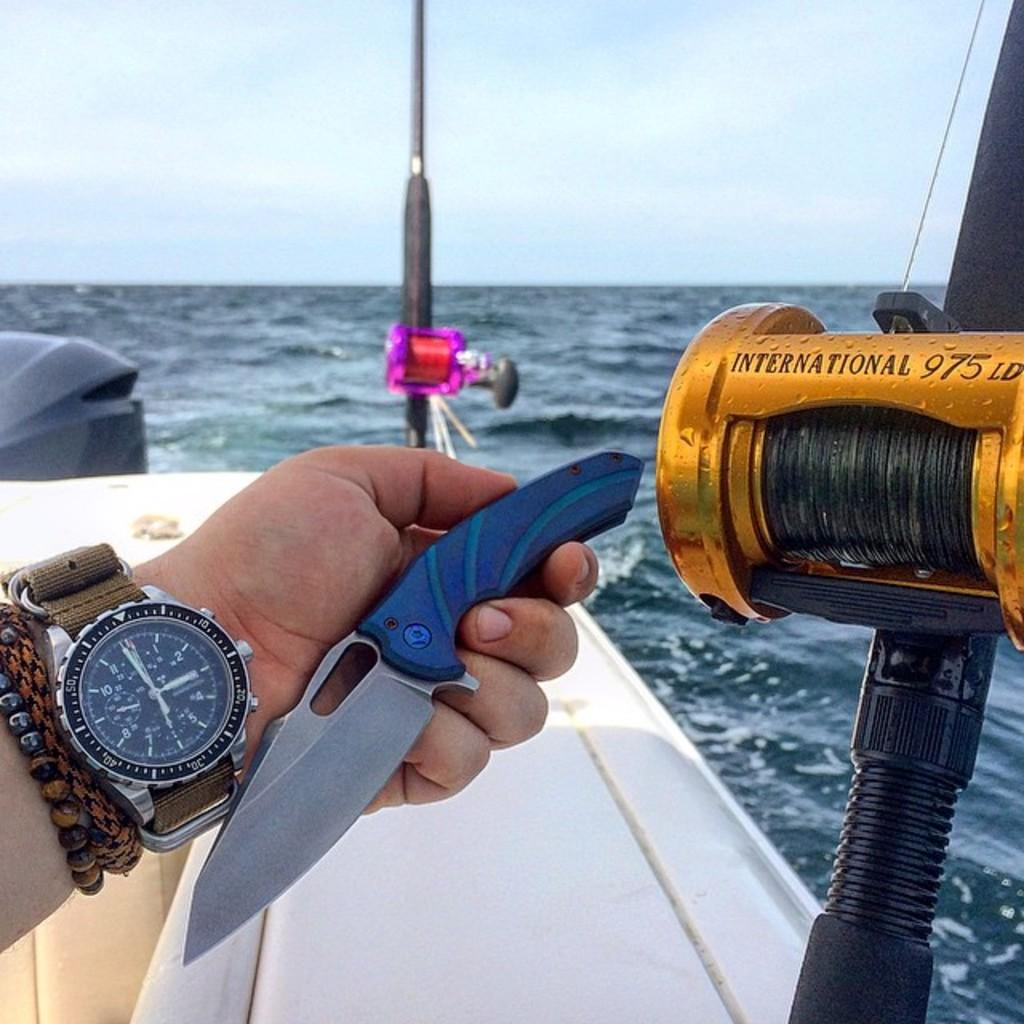<image>
Summarize the visual content of the image. A man is holding a knife in his hand while fishing at 2:59 pm. 